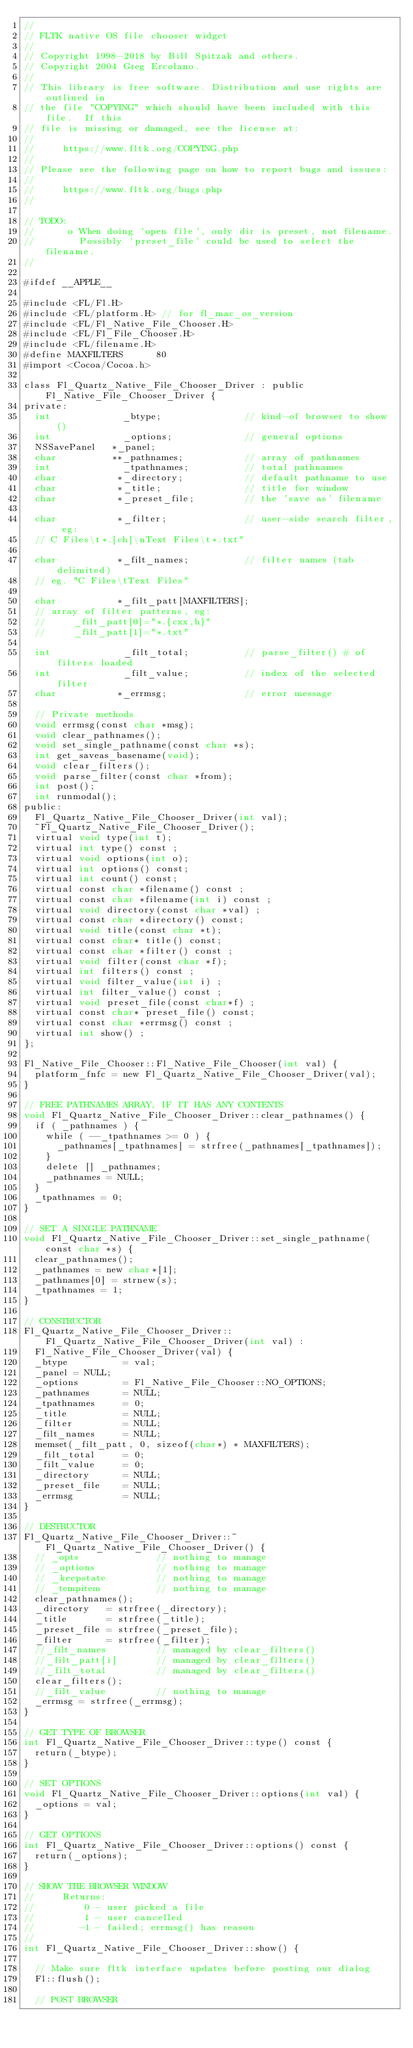<code> <loc_0><loc_0><loc_500><loc_500><_ObjectiveC_>//
// FLTK native OS file chooser widget
//
// Copyright 1998-2018 by Bill Spitzak and others.
// Copyright 2004 Greg Ercolano.
//
// This library is free software. Distribution and use rights are outlined in
// the file "COPYING" which should have been included with this file.  If this
// file is missing or damaged, see the license at:
//
//     https://www.fltk.org/COPYING.php
//
// Please see the following page on how to report bugs and issues:
//
//     https://www.fltk.org/bugs.php
//

// TODO:
//      o When doing 'open file', only dir is preset, not filename.
//        Possibly 'preset_file' could be used to select the filename.
//

#ifdef __APPLE__

#include <FL/Fl.H>
#include <FL/platform.H> // for fl_mac_os_version
#include <FL/Fl_Native_File_Chooser.H>
#include <FL/Fl_File_Chooser.H>
#include <FL/filename.H>
#define MAXFILTERS      80
#import <Cocoa/Cocoa.h>

class Fl_Quartz_Native_File_Chooser_Driver : public Fl_Native_File_Chooser_Driver {
private:
  int             _btype;               // kind-of browser to show()
  int             _options;             // general options
  NSSavePanel   *_panel;
  char          **_pathnames;           // array of pathnames
  int             _tpathnames;          // total pathnames
  char           *_directory;           // default pathname to use
  char           *_title;               // title for window
  char           *_preset_file;         // the 'save as' filename

  char           *_filter;              // user-side search filter, eg:
  // C Files\t*.[ch]\nText Files\t*.txt"

  char           *_filt_names;          // filter names (tab delimited)
  // eg. "C Files\tText Files"

  char           *_filt_patt[MAXFILTERS];
  // array of filter patterns, eg:
  //     _filt_patt[0]="*.{cxx,h}"
  //     _filt_patt[1]="*.txt"

  int             _filt_total;          // parse_filter() # of filters loaded
  int             _filt_value;          // index of the selected filter
  char           *_errmsg;              // error message

  // Private methods
  void errmsg(const char *msg);
  void clear_pathnames();
  void set_single_pathname(const char *s);
  int get_saveas_basename(void);
  void clear_filters();
  void parse_filter(const char *from);
  int post();
  int runmodal();
public:
  Fl_Quartz_Native_File_Chooser_Driver(int val);
  ~Fl_Quartz_Native_File_Chooser_Driver();
  virtual void type(int t);
  virtual int type() const ;
  virtual void options(int o);
  virtual int options() const;
  virtual int count() const;
  virtual const char *filename() const ;
  virtual const char *filename(int i) const ;
  virtual void directory(const char *val) ;
  virtual const char *directory() const;
  virtual void title(const char *t);
  virtual const char* title() const;
  virtual const char *filter() const ;
  virtual void filter(const char *f);
  virtual int filters() const ;
  virtual void filter_value(int i) ;
  virtual int filter_value() const ;
  virtual void preset_file(const char*f) ;
  virtual const char* preset_file() const;
  virtual const char *errmsg() const ;
  virtual int show() ;
};

Fl_Native_File_Chooser::Fl_Native_File_Chooser(int val) {
  platform_fnfc = new Fl_Quartz_Native_File_Chooser_Driver(val);
}

// FREE PATHNAMES ARRAY, IF IT HAS ANY CONTENTS
void Fl_Quartz_Native_File_Chooser_Driver::clear_pathnames() {
  if ( _pathnames ) {
    while ( --_tpathnames >= 0 ) {
      _pathnames[_tpathnames] = strfree(_pathnames[_tpathnames]);
    }
    delete [] _pathnames;
    _pathnames = NULL;
  }
  _tpathnames = 0;
}

// SET A SINGLE PATHNAME
void Fl_Quartz_Native_File_Chooser_Driver::set_single_pathname(const char *s) {
  clear_pathnames();
  _pathnames = new char*[1];
  _pathnames[0] = strnew(s);
  _tpathnames = 1;
}

// CONSTRUCTOR
Fl_Quartz_Native_File_Chooser_Driver::Fl_Quartz_Native_File_Chooser_Driver(int val) :
  Fl_Native_File_Chooser_Driver(val) {
  _btype          = val;
  _panel = NULL;
  _options        = Fl_Native_File_Chooser::NO_OPTIONS;
  _pathnames      = NULL;
  _tpathnames     = 0;
  _title          = NULL;
  _filter         = NULL;
  _filt_names     = NULL;
  memset(_filt_patt, 0, sizeof(char*) * MAXFILTERS);
  _filt_total     = 0;
  _filt_value     = 0;
  _directory      = NULL;
  _preset_file    = NULL;
  _errmsg         = NULL;
}

// DESTRUCTOR
Fl_Quartz_Native_File_Chooser_Driver::~Fl_Quartz_Native_File_Chooser_Driver() {
  // _opts              // nothing to manage
  // _options           // nothing to manage
  // _keepstate         // nothing to manage
  // _tempitem          // nothing to manage
  clear_pathnames();
  _directory   = strfree(_directory);
  _title       = strfree(_title);
  _preset_file = strfree(_preset_file);
  _filter      = strfree(_filter);
  //_filt_names         // managed by clear_filters()
  //_filt_patt[i]       // managed by clear_filters()
  //_filt_total         // managed by clear_filters()
  clear_filters();
  //_filt_value         // nothing to manage
  _errmsg = strfree(_errmsg);
}

// GET TYPE OF BROWSER
int Fl_Quartz_Native_File_Chooser_Driver::type() const {
  return(_btype);
}

// SET OPTIONS
void Fl_Quartz_Native_File_Chooser_Driver::options(int val) {
  _options = val;
}

// GET OPTIONS
int Fl_Quartz_Native_File_Chooser_Driver::options() const {
  return(_options);
}

// SHOW THE BROWSER WINDOW
//     Returns:
//         0 - user picked a file
//         1 - user cancelled
//        -1 - failed; errmsg() has reason
//
int Fl_Quartz_Native_File_Chooser_Driver::show() {

  // Make sure fltk interface updates before posting our dialog
  Fl::flush();

  // POST BROWSER</code> 